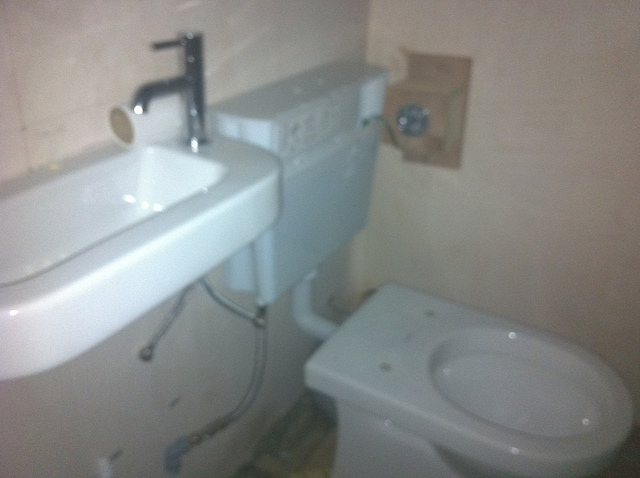What sort of lighting is present in this bathroom? The image does not show any direct lighting fixtures, but the overall illumination appears to come from a light source outside of the frame, likely a ceiling fixture. How can this bathroom be improved? Adding a toilet seat for comfort, a mirror above the sink, and potentially some shelving or cabinets for storage could greatly enhance this bathroom's functionality and appearance. 